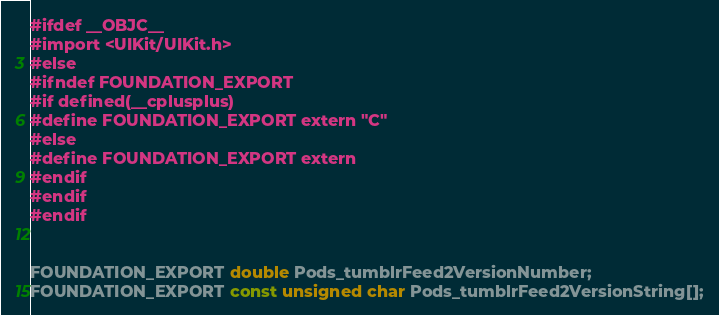Convert code to text. <code><loc_0><loc_0><loc_500><loc_500><_C_>#ifdef __OBJC__
#import <UIKit/UIKit.h>
#else
#ifndef FOUNDATION_EXPORT
#if defined(__cplusplus)
#define FOUNDATION_EXPORT extern "C"
#else
#define FOUNDATION_EXPORT extern
#endif
#endif
#endif


FOUNDATION_EXPORT double Pods_tumblrFeed2VersionNumber;
FOUNDATION_EXPORT const unsigned char Pods_tumblrFeed2VersionString[];

</code> 